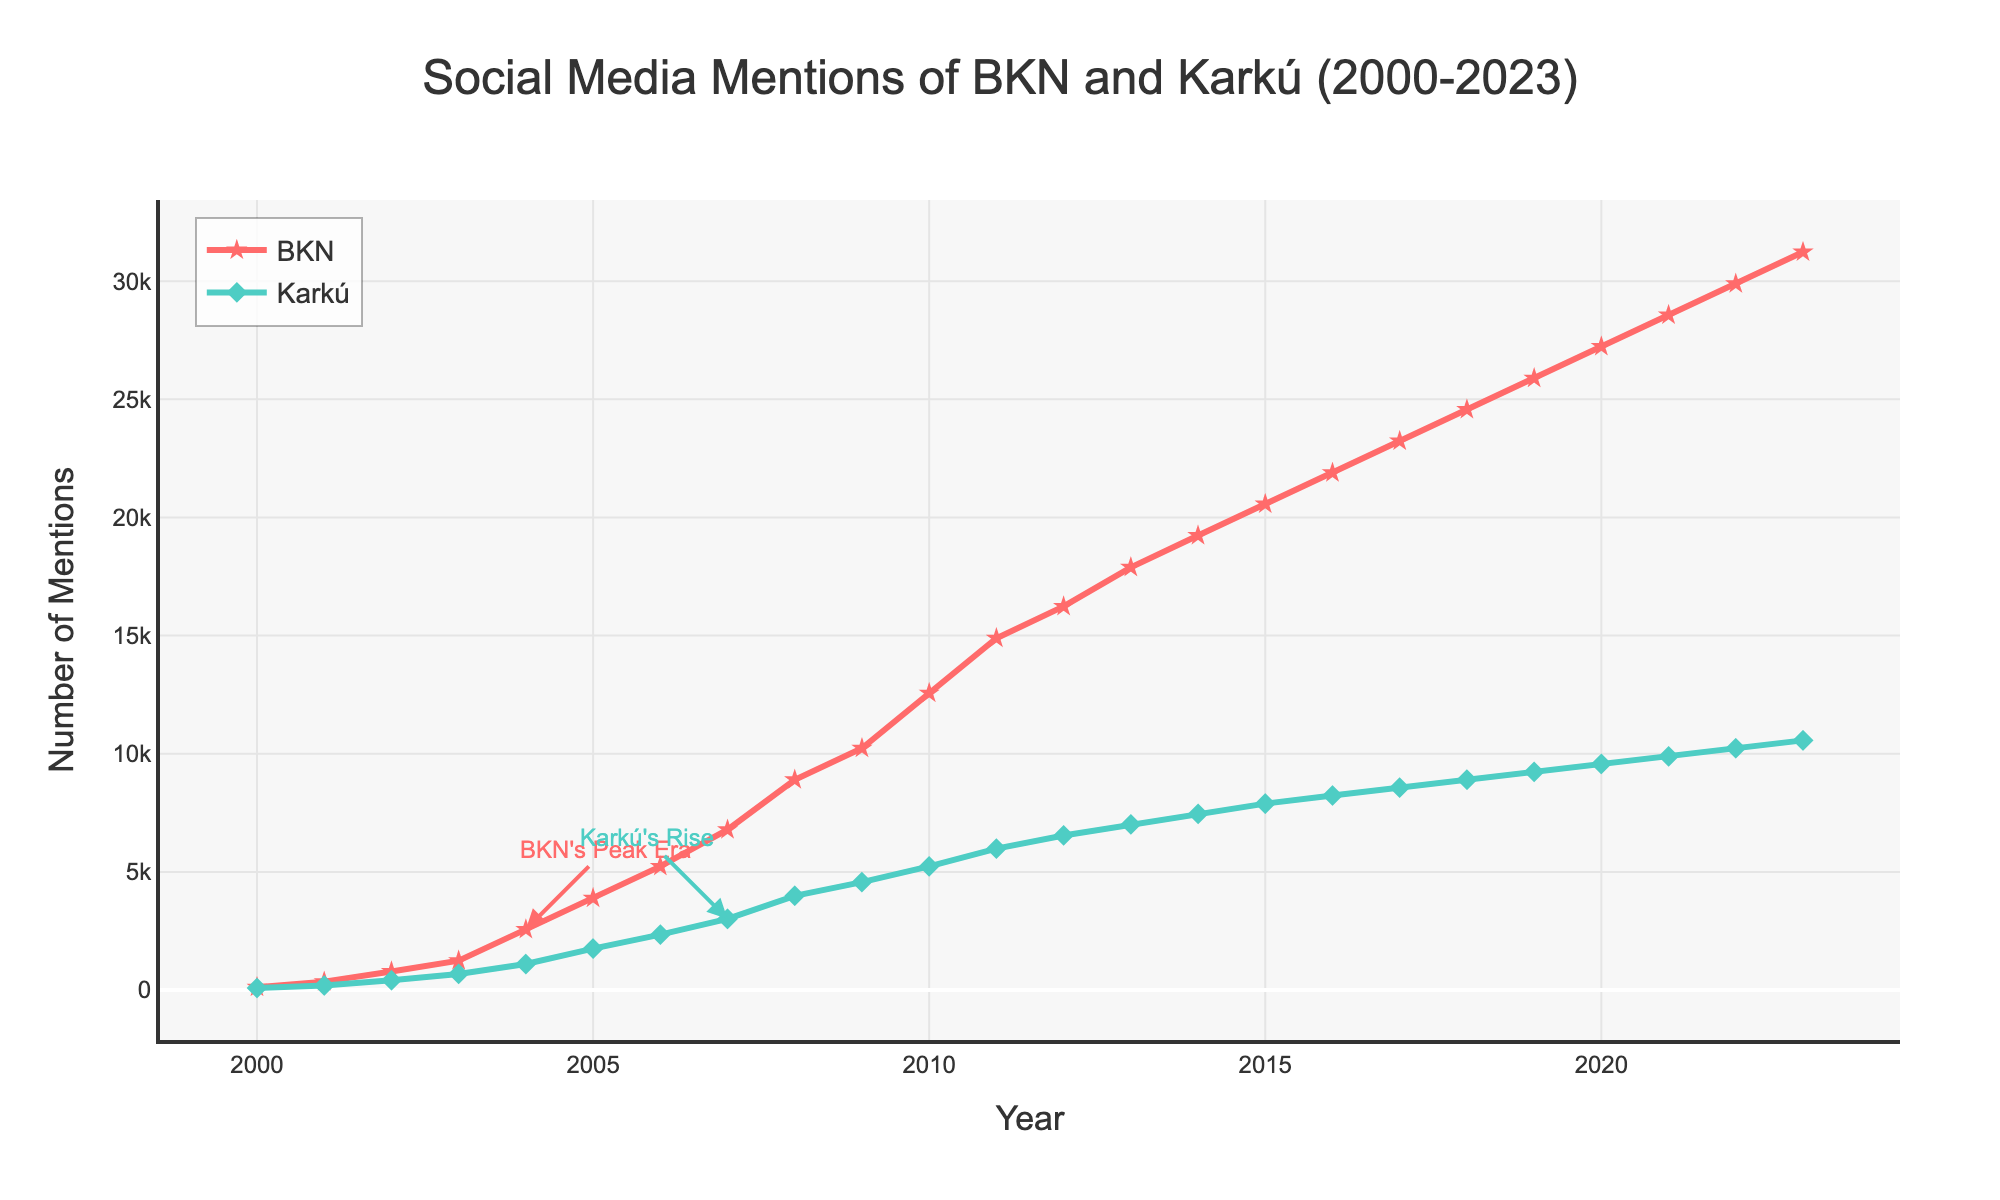What is the peak number of mentions for BKN, and in which year did it occur? The peak number of mentions for BKN is found by identifying the highest point on the BKN line. It occurs at 31234 mentions in the year 2023.
Answer: 31234 in 2023 When did Karkú experience its most significant increase in mentions, and what was the difference in mentions between the two years? The most significant increase for Karkú is observed by looking at the steepest increase on the Karkú line. It occurs from 2007 (3012 mentions) to 2008 (3987 mentions), with a difference of 3987 - 3012 = 975 mentions.
Answer: 2007 to 2008, increase of 975 mentions Compare the number of mentions for BKN and Karkú in 2010. Which one had more mentions and by how much? In 2010, BKN had 12567 mentions, and Karkú had 5234 mentions. BKN had more mentions by 12567 - 5234 = 7333.
Answer: BKN by 7333 Which year saw the most significant difference in mentions between BKN and Karkú, and what is the value of that difference? The most significant difference between BKN and Karkú is found by calculating the absolute differences for each year and identifying the largest one. In 2023, the difference is 31234 - 10567 = 20667, the highest among the years.
Answer: 2023, 20667 How have the trends in social media mentions for BKN and Karkú changed from 2000 to 2023? To analyze the trends, observe the general direction and rate of increase for each line. BKN started with fewer mentions but saw a sharp and consistent rise over the years, especially from 2004 onwards. Karkú also increased but at a slower pace compared to BKN. Both show upward trends, with BKN rising more steeply.
Answer: Both upward, BKN steeper 